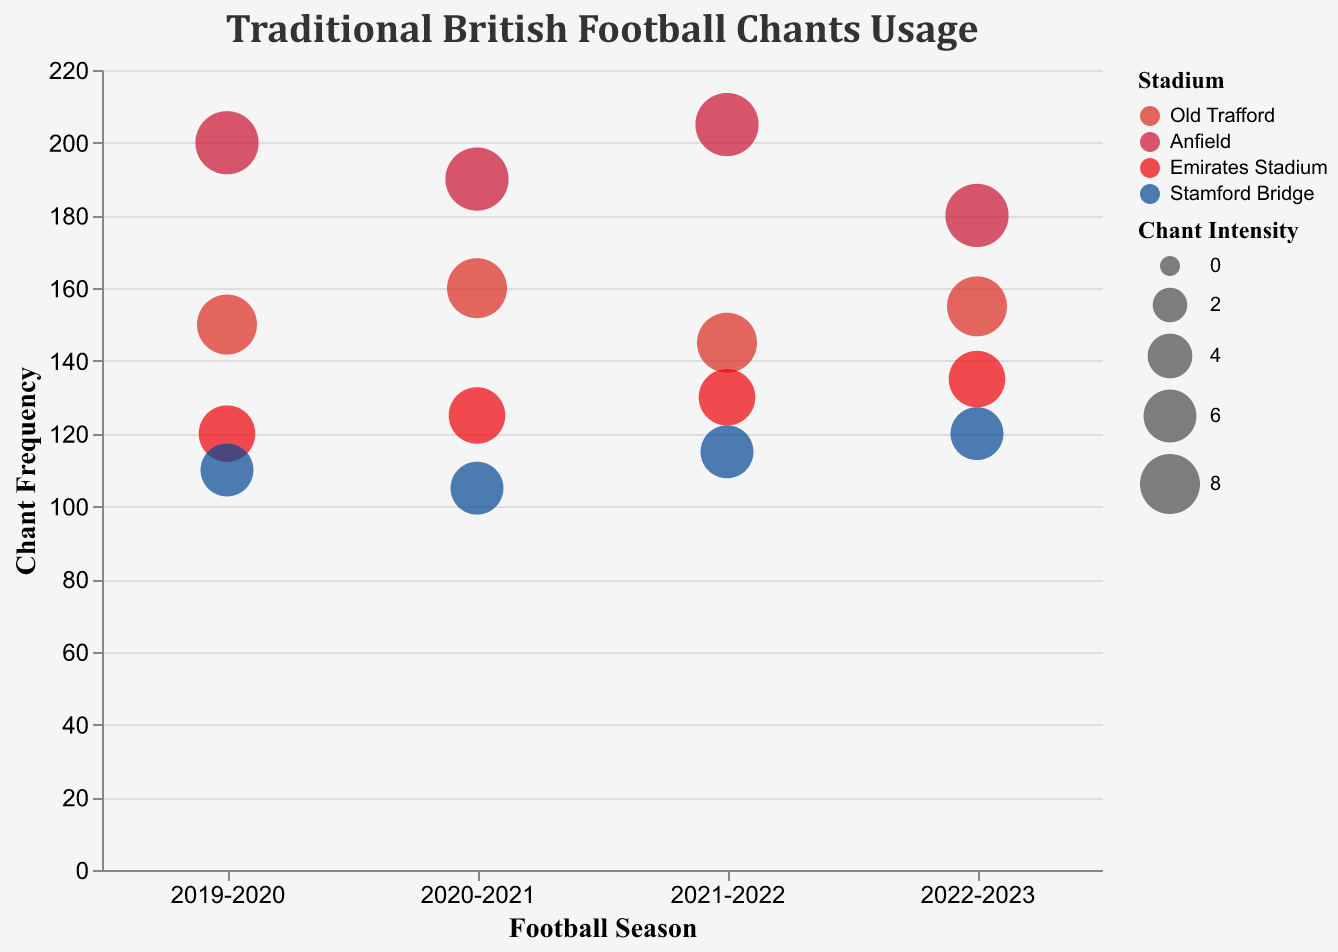What is the frequency of the chant "You'll Never Walk Alone" at Anfield in the season 2019-2020? Look for the bubble corresponding to Anfield for the season 2019-2020. The tooltip or the bubble size can give you the value.
Answer: 200 How does the frequency of "Chelsea Till I Die" in the 2021-2022 season compare to the 2020-2021 season at Stamford Bridge? Find the bubbles for Stamford Bridge for both seasons and compare their y-axis positions.
Answer: 115 vs 105 Which stadium has the highest chant frequency in the 2022-2023 season? Look for the highest bubble on the y-axis labeled with the 2022-2023 season and check its color or tooltip.
Answer: Anfield What is the average chant intensity at Old Trafford across all four seasons? Identify the relevant bubbles for Old Trafford, collect the intensity values (8, 8, 8, 8), and calculate the average.
Answer: 8 Which season had the lowest chant frequency at Emirates Stadium? Look at the position of the bubbles corresponding to Emirates Stadium and find the one with the lowest y-axis value.
Answer: 2019-2020 How does the frequency of chants at Anfield generally trend over these seasons? Observe the y-axis positions for Anfield over the four seasons and determine the trend direction (increase, decrease, etc.).
Answer: Increasing trend What is the total frequency for the chant "Glory Glory Man United" across all seasons at Old Trafford? Sum the frequencies of the chant across the four seasons: 150 + 160 + 145 + 155.
Answer: 610 Which stadium has consistently high intensity for their chants? Compare the intensities shown by the size of the bubbles. Focus on those with consistently large bubbles.
Answer: Anfield What is the difference in chant frequency for "We Love You Arsenal" between the 2019-2020 and 2022-2023 seasons? Subtract the frequency of the chant in 2019-2020 from that in 2022-2023.
Answer: 15 